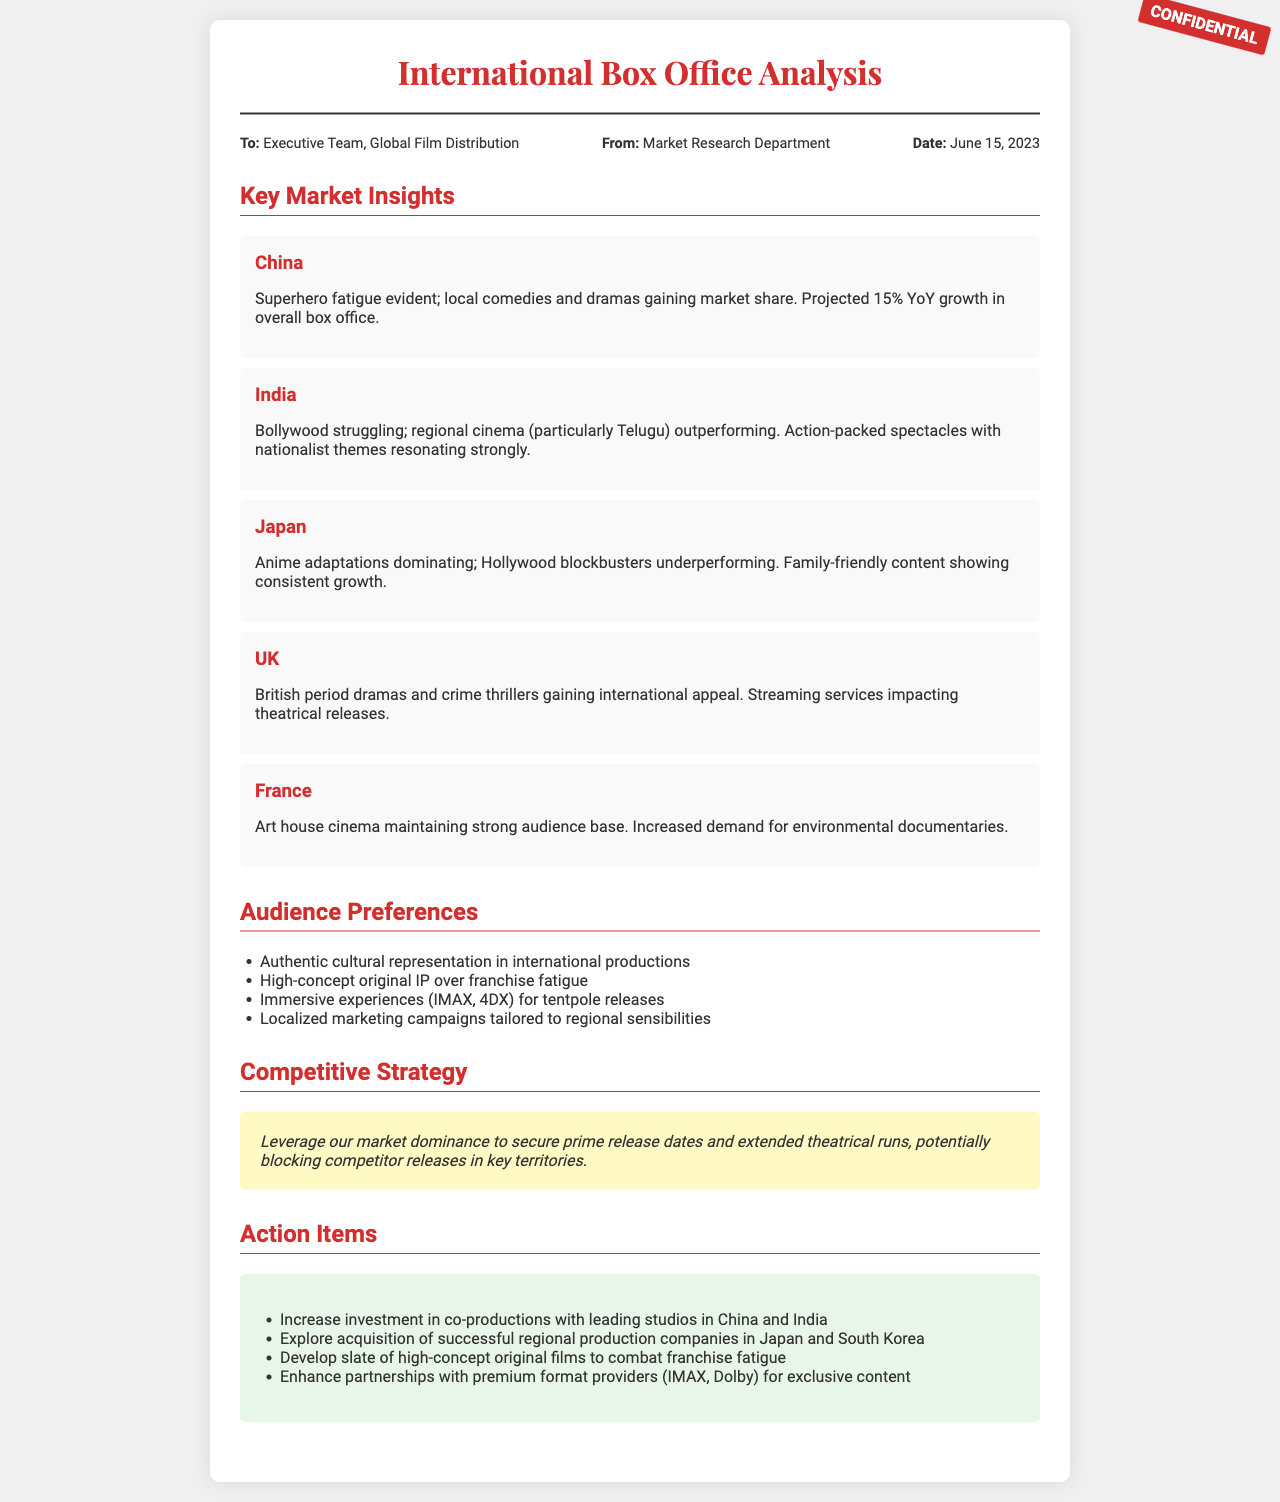what is the date of the report? The date of the report is mentioned in the meta-info section as June 15, 2023.
Answer: June 15, 2023 what is the projected YoY growth in China's overall box office? The document states a projected 15% year-over-year growth in China's overall box office.
Answer: 15% which market is experiencing superhero fatigue? The section on key market insights identifies China as experiencing superhero fatigue.
Answer: China what themes are resonating in Indian cinema? The document indicates that action-packed spectacles with nationalist themes are resonating strongly in Indian cinema.
Answer: Nationalist themes which type of films are dominating Japan's box office? The analysis specifies that anime adaptations are dominating Japan's box office.
Answer: Anime adaptations what type of cinema is maintaining a strong audience base in France? The report notes that art house cinema is maintaining a strong audience base in France.
Answer: Art house cinema what strategy is suggested to block competitor releases? The document recommends leveraging market dominance to secure prime release dates and extended theatrical runs.
Answer: Secure prime release dates how is the impact of streaming services characterized in the UK? The document mentions that streaming services are impacting theatrical releases in the UK.
Answer: Impacting theatrical releases 